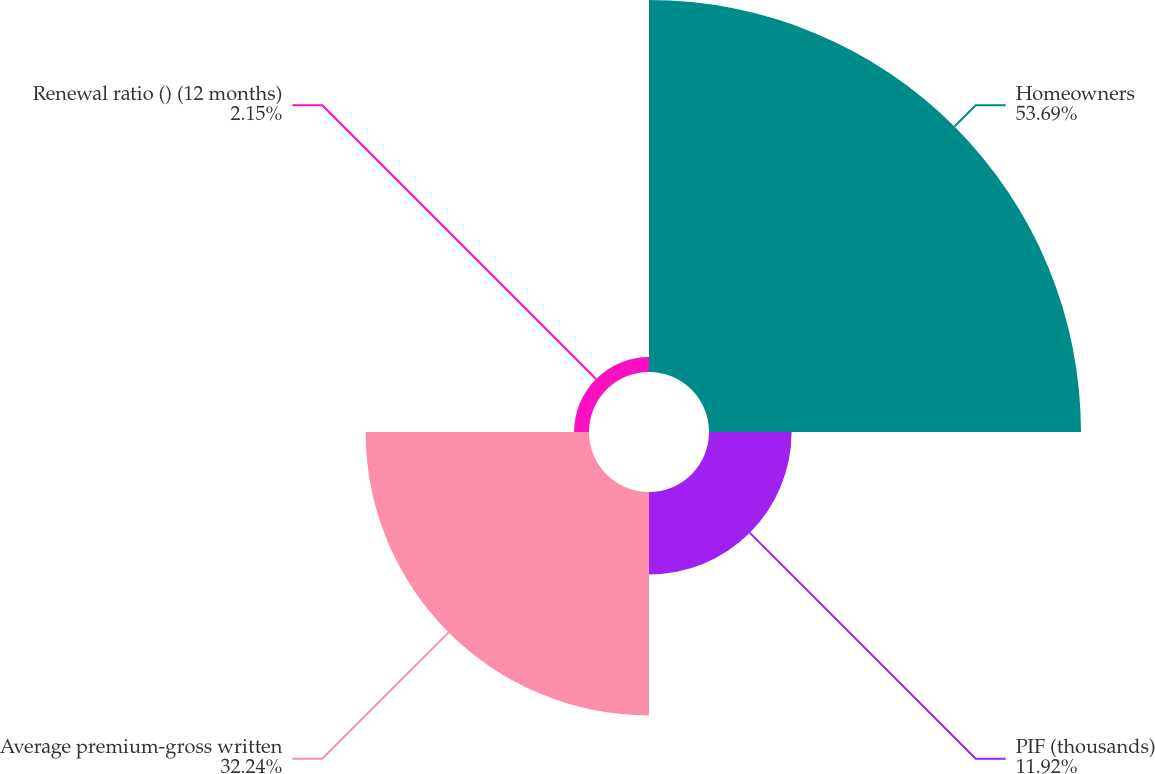Convert chart to OTSL. <chart><loc_0><loc_0><loc_500><loc_500><pie_chart><fcel>Homeowners<fcel>PIF (thousands)<fcel>Average premium-gross written<fcel>Renewal ratio () (12 months)<nl><fcel>53.68%<fcel>11.92%<fcel>32.24%<fcel>2.15%<nl></chart> 